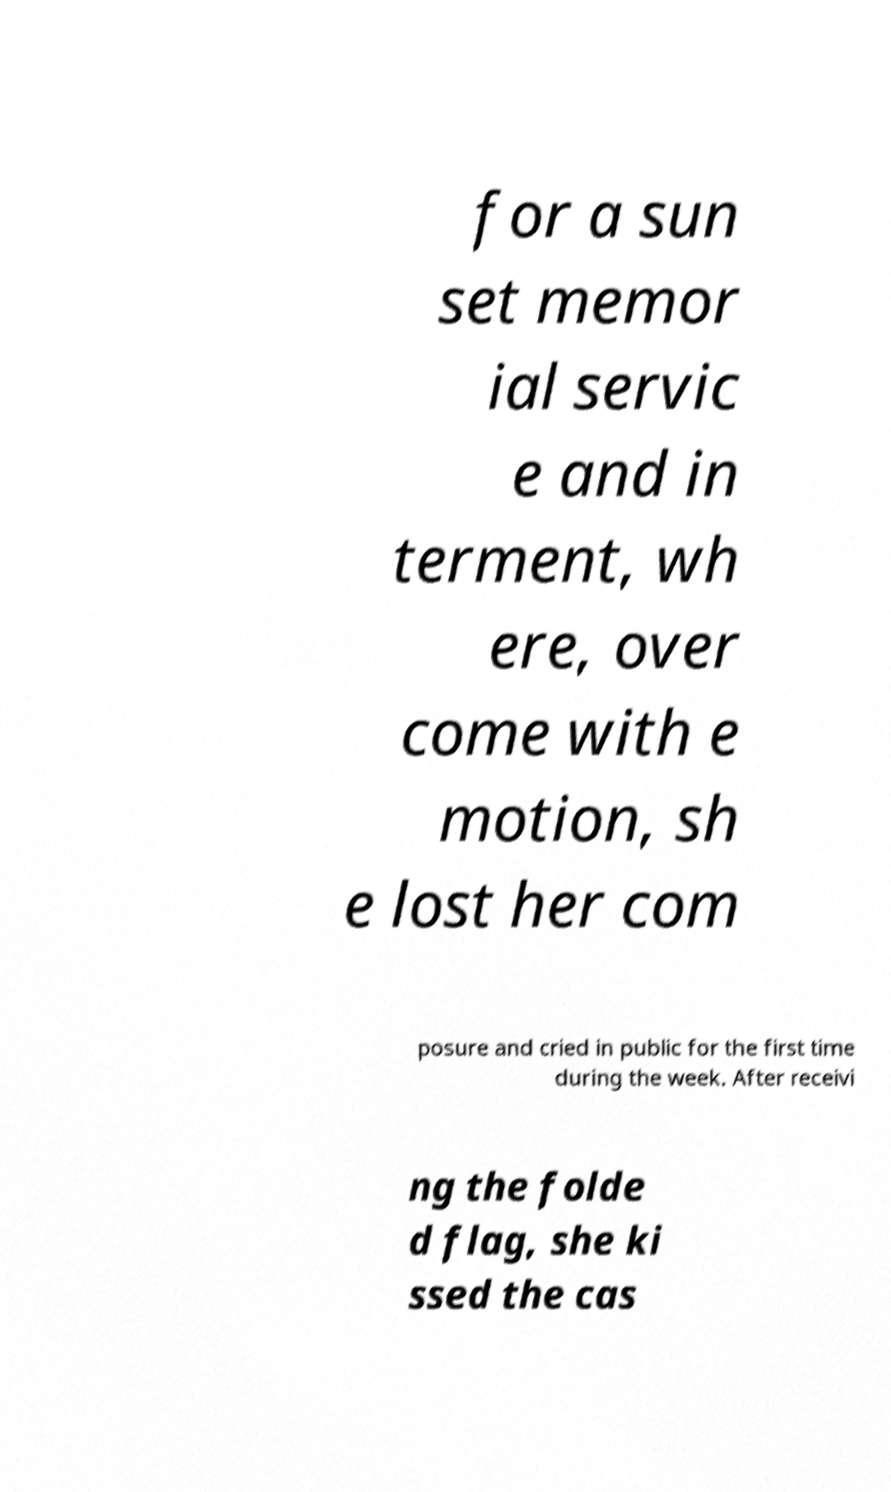Can you accurately transcribe the text from the provided image for me? for a sun set memor ial servic e and in terment, wh ere, over come with e motion, sh e lost her com posure and cried in public for the first time during the week. After receivi ng the folde d flag, she ki ssed the cas 